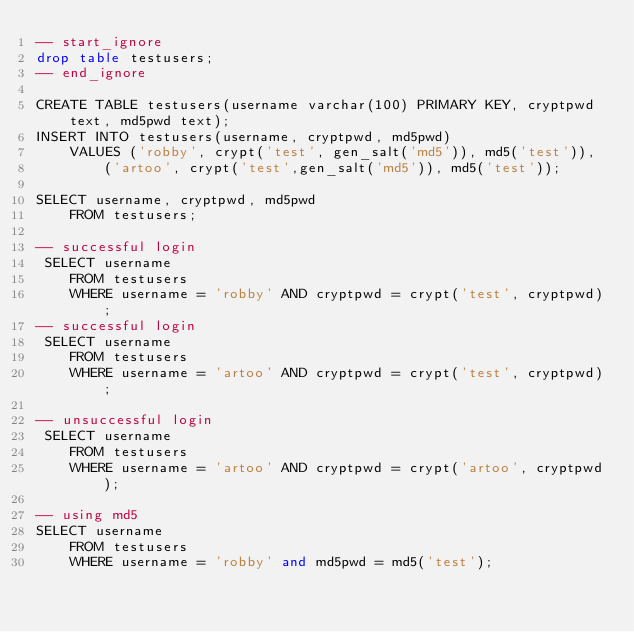Convert code to text. <code><loc_0><loc_0><loc_500><loc_500><_SQL_>-- start_ignore
drop table testusers;
-- end_ignore

CREATE TABLE testusers(username varchar(100) PRIMARY KEY, cryptpwd text, md5pwd text);
INSERT INTO testusers(username, cryptpwd, md5pwd) 
    VALUES ('robby', crypt('test', gen_salt('md5')), md5('test')),
        ('artoo', crypt('test',gen_salt('md5')), md5('test'));
        
SELECT username, cryptpwd, md5pwd
    FROM testusers;

-- successful login
 SELECT username 
    FROM testusers 
    WHERE username = 'robby' AND cryptpwd = crypt('test', cryptpwd);
-- successful login     
 SELECT username 
    FROM testusers 
    WHERE username = 'artoo' AND cryptpwd = crypt('test', cryptpwd);
    
-- unsuccessful login
 SELECT username 
    FROM testusers 
    WHERE username = 'artoo' AND cryptpwd = crypt('artoo', cryptpwd);
    
-- using md5
SELECT username
    FROM testusers
    WHERE username = 'robby' and md5pwd = md5('test');
</code> 